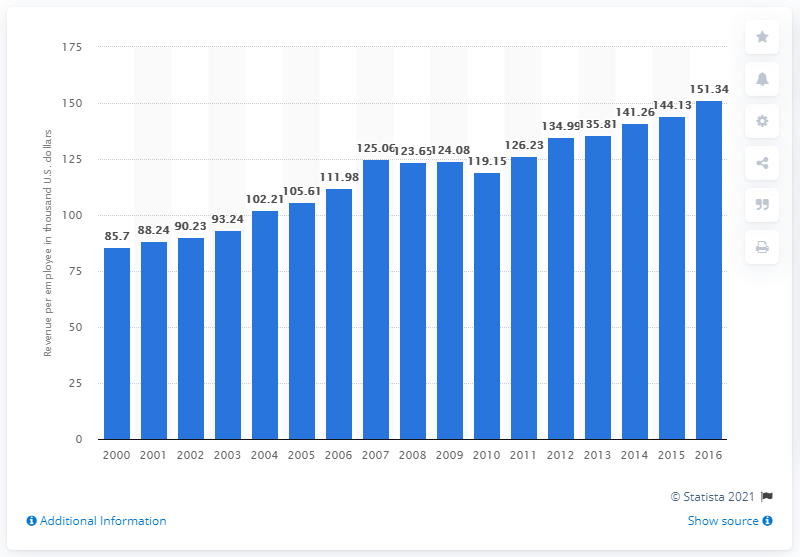Outline some significant characteristics in this image. In 2012, the average revenue per employee in casinos in Nevada was 135.81 dollars. 